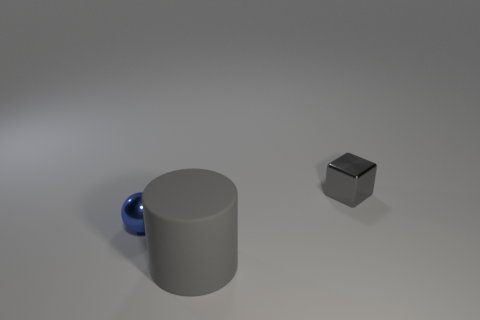Add 2 tiny gray metal things. How many objects exist? 5 Subtract all balls. How many objects are left? 2 Subtract all large objects. Subtract all small metal balls. How many objects are left? 1 Add 1 big gray objects. How many big gray objects are left? 2 Add 1 blue shiny balls. How many blue shiny balls exist? 2 Subtract 0 yellow cylinders. How many objects are left? 3 